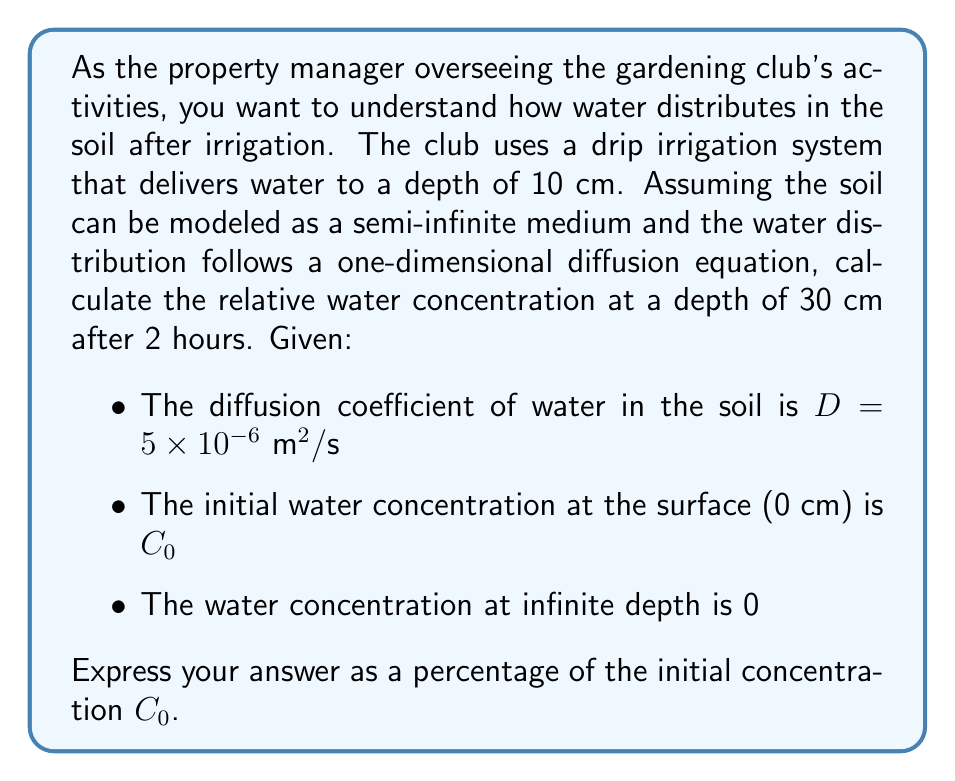Can you answer this question? To solve this problem, we need to use the solution to the one-dimensional diffusion equation for a semi-infinite medium with a constant surface concentration. The equation that describes this situation is:

$$\frac{C(x,t) - C_{\infty}}{C_0 - C_{\infty}} = \text{erfc}\left(\frac{x}{2\sqrt{Dt}}\right)$$

Where:
- $C(x,t)$ is the concentration at depth $x$ and time $t$
- $C_0$ is the initial concentration at the surface
- $C_{\infty}$ is the concentration at infinite depth (given as 0)
- $\text{erfc}$ is the complementary error function

Let's plug in our values:
- $x = 30 \text{ cm} = 0.3 \text{ m}$ (depth)
- $t = 2 \text{ hours} = 7200 \text{ s}$ (time)
- $D = 5 \times 10^{-6} \text{ m}^2/\text{s}$ (diffusion coefficient)

First, calculate the argument of the erfc function:

$$\frac{x}{2\sqrt{Dt}} = \frac{0.3}{2\sqrt{(5 \times 10^{-6})(7200)}} \approx 0.7906$$

Now, we need to find $\text{erfc}(0.7906)$. Using a calculator or mathematical software, we get:

$$\text{erfc}(0.7906) \approx 0.2391$$

Substituting this back into our original equation:

$$\frac{C(0.3,7200) - 0}{C_0 - 0} = 0.2391$$

Simplifying:

$$\frac{C(0.3,7200)}{C_0} = 0.2391$$

To express this as a percentage of the initial concentration:

$$\frac{C(0.3,7200)}{C_0} \times 100\% = 23.91\%$$
Answer: The relative water concentration at a depth of 30 cm after 2 hours is approximately 23.91% of the initial surface concentration $C_0$. 